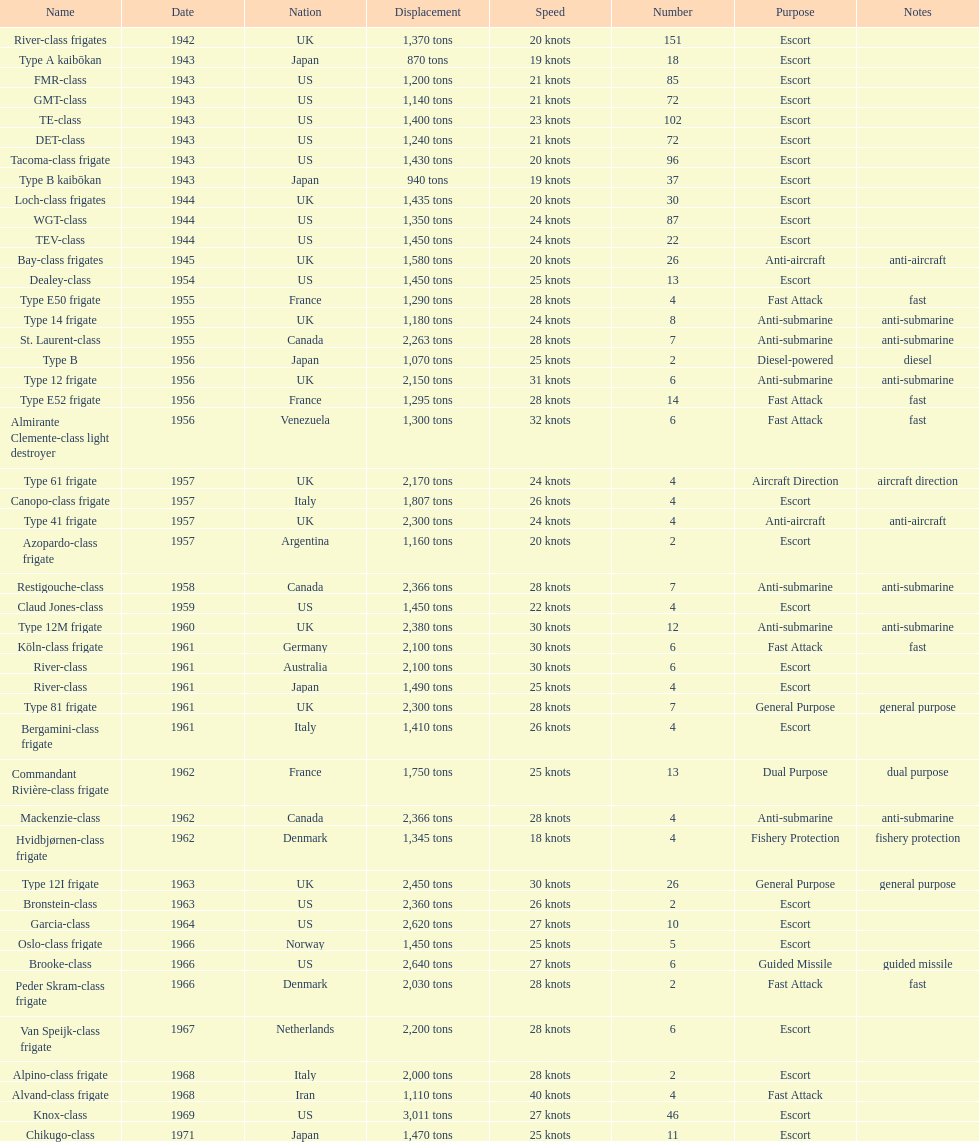Which of the boats listed is the fastest? Alvand-class frigate. 